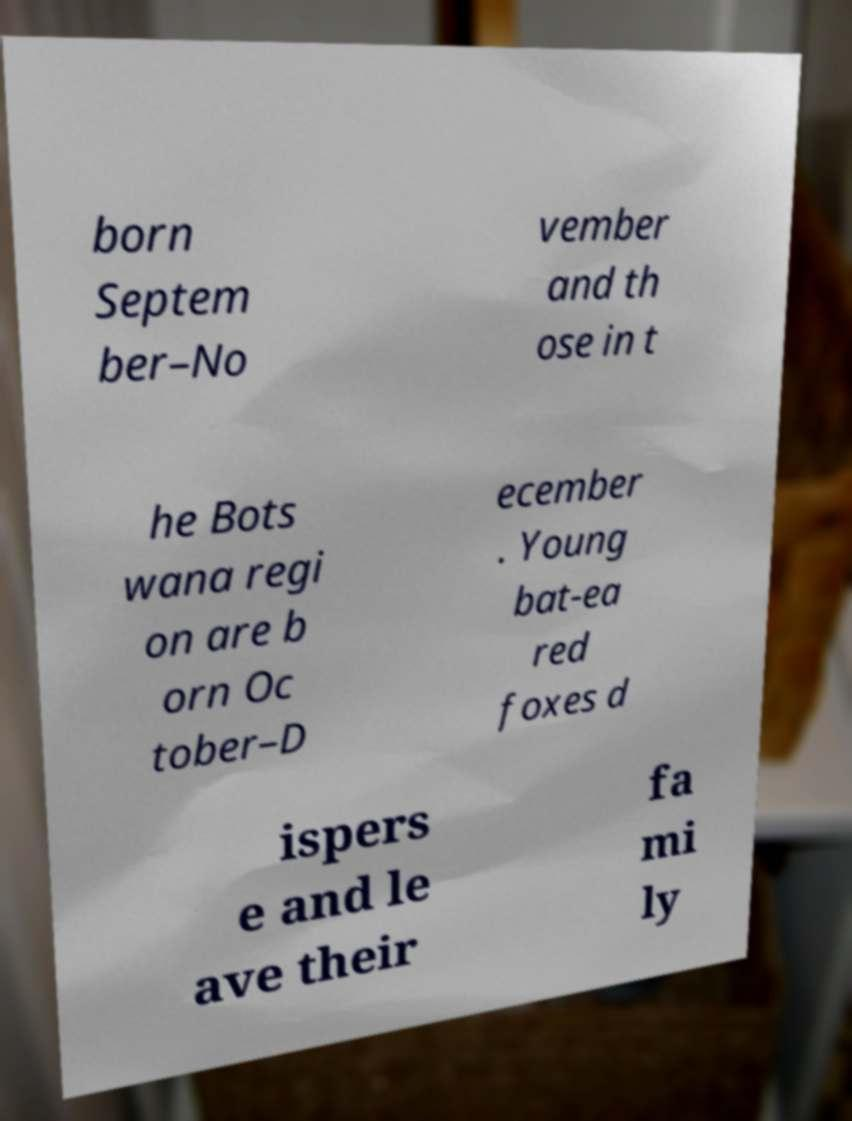I need the written content from this picture converted into text. Can you do that? born Septem ber–No vember and th ose in t he Bots wana regi on are b orn Oc tober–D ecember . Young bat-ea red foxes d ispers e and le ave their fa mi ly 